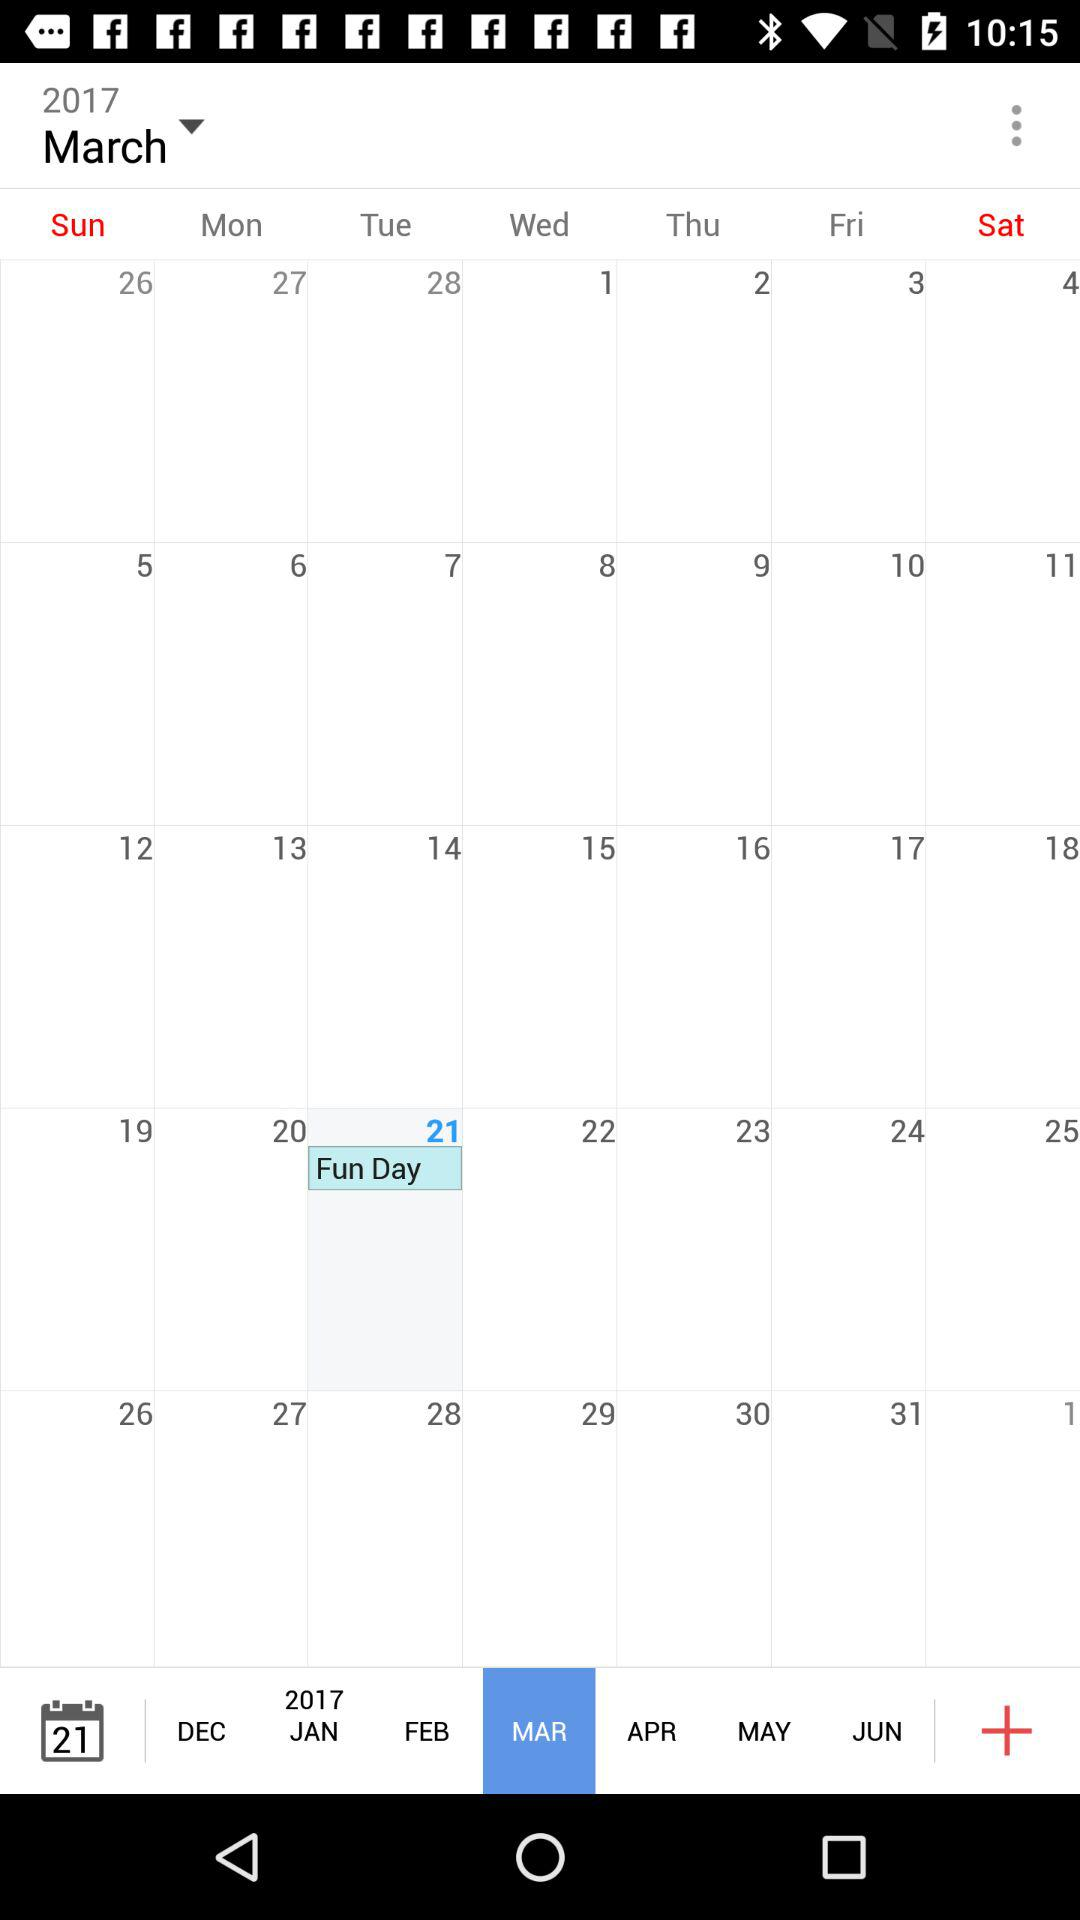What is on 21st of March? On March 21, it is Fun Day. 